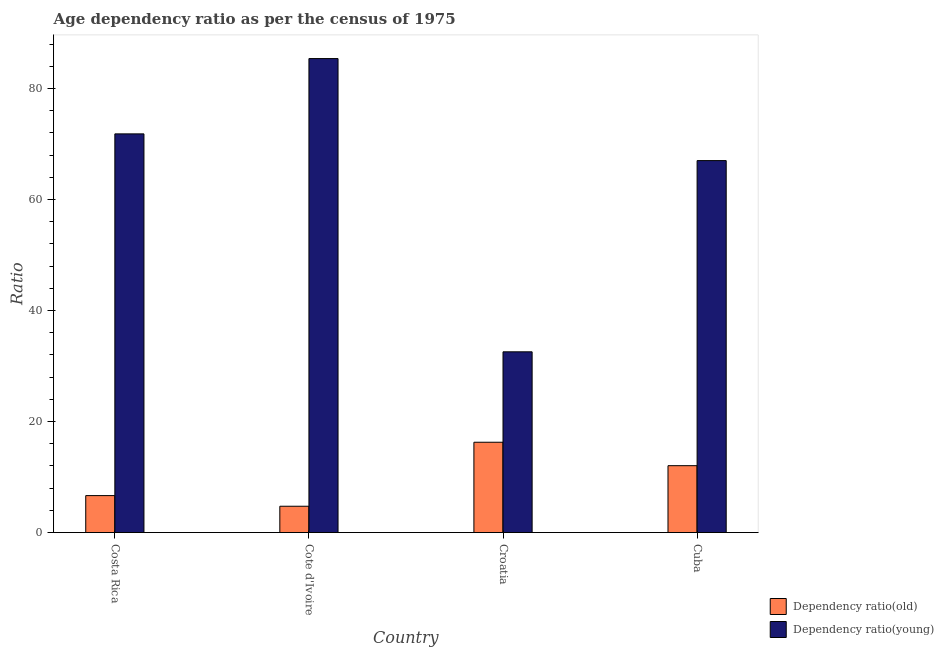Are the number of bars on each tick of the X-axis equal?
Offer a terse response. Yes. What is the label of the 2nd group of bars from the left?
Make the answer very short. Cote d'Ivoire. What is the age dependency ratio(young) in Croatia?
Give a very brief answer. 32.57. Across all countries, what is the maximum age dependency ratio(old)?
Make the answer very short. 16.28. Across all countries, what is the minimum age dependency ratio(old)?
Your answer should be very brief. 4.75. In which country was the age dependency ratio(old) maximum?
Offer a very short reply. Croatia. In which country was the age dependency ratio(young) minimum?
Ensure brevity in your answer.  Croatia. What is the total age dependency ratio(old) in the graph?
Your answer should be compact. 39.75. What is the difference between the age dependency ratio(young) in Croatia and that in Cuba?
Your answer should be very brief. -34.46. What is the difference between the age dependency ratio(old) in Croatia and the age dependency ratio(young) in Cote d'Ivoire?
Your response must be concise. -69.13. What is the average age dependency ratio(young) per country?
Your answer should be compact. 64.21. What is the difference between the age dependency ratio(old) and age dependency ratio(young) in Croatia?
Offer a very short reply. -16.29. In how many countries, is the age dependency ratio(young) greater than 4 ?
Offer a terse response. 4. What is the ratio of the age dependency ratio(old) in Croatia to that in Cuba?
Offer a terse response. 1.35. Is the age dependency ratio(young) in Costa Rica less than that in Cote d'Ivoire?
Your answer should be very brief. Yes. Is the difference between the age dependency ratio(old) in Costa Rica and Cuba greater than the difference between the age dependency ratio(young) in Costa Rica and Cuba?
Provide a succinct answer. No. What is the difference between the highest and the second highest age dependency ratio(old)?
Make the answer very short. 4.22. What is the difference between the highest and the lowest age dependency ratio(old)?
Your response must be concise. 11.53. In how many countries, is the age dependency ratio(young) greater than the average age dependency ratio(young) taken over all countries?
Ensure brevity in your answer.  3. Is the sum of the age dependency ratio(old) in Costa Rica and Cuba greater than the maximum age dependency ratio(young) across all countries?
Provide a short and direct response. No. What does the 2nd bar from the left in Croatia represents?
Provide a succinct answer. Dependency ratio(young). What does the 1st bar from the right in Costa Rica represents?
Provide a succinct answer. Dependency ratio(young). How many countries are there in the graph?
Your response must be concise. 4. What is the difference between two consecutive major ticks on the Y-axis?
Provide a short and direct response. 20. Are the values on the major ticks of Y-axis written in scientific E-notation?
Your answer should be compact. No. Does the graph contain any zero values?
Keep it short and to the point. No. Does the graph contain grids?
Your answer should be very brief. No. How are the legend labels stacked?
Your answer should be very brief. Vertical. What is the title of the graph?
Provide a short and direct response. Age dependency ratio as per the census of 1975. What is the label or title of the Y-axis?
Your answer should be very brief. Ratio. What is the Ratio of Dependency ratio(old) in Costa Rica?
Your response must be concise. 6.67. What is the Ratio in Dependency ratio(young) in Costa Rica?
Your answer should be very brief. 71.84. What is the Ratio in Dependency ratio(old) in Cote d'Ivoire?
Your answer should be compact. 4.75. What is the Ratio in Dependency ratio(young) in Cote d'Ivoire?
Give a very brief answer. 85.41. What is the Ratio in Dependency ratio(old) in Croatia?
Provide a short and direct response. 16.28. What is the Ratio of Dependency ratio(young) in Croatia?
Your answer should be very brief. 32.57. What is the Ratio of Dependency ratio(old) in Cuba?
Your answer should be compact. 12.06. What is the Ratio in Dependency ratio(young) in Cuba?
Your answer should be compact. 67.02. Across all countries, what is the maximum Ratio in Dependency ratio(old)?
Provide a succinct answer. 16.28. Across all countries, what is the maximum Ratio in Dependency ratio(young)?
Ensure brevity in your answer.  85.41. Across all countries, what is the minimum Ratio in Dependency ratio(old)?
Offer a very short reply. 4.75. Across all countries, what is the minimum Ratio in Dependency ratio(young)?
Offer a very short reply. 32.57. What is the total Ratio of Dependency ratio(old) in the graph?
Provide a succinct answer. 39.75. What is the total Ratio in Dependency ratio(young) in the graph?
Your answer should be very brief. 256.84. What is the difference between the Ratio in Dependency ratio(old) in Costa Rica and that in Cote d'Ivoire?
Ensure brevity in your answer.  1.92. What is the difference between the Ratio in Dependency ratio(young) in Costa Rica and that in Cote d'Ivoire?
Give a very brief answer. -13.57. What is the difference between the Ratio of Dependency ratio(old) in Costa Rica and that in Croatia?
Provide a short and direct response. -9.61. What is the difference between the Ratio in Dependency ratio(young) in Costa Rica and that in Croatia?
Provide a succinct answer. 39.27. What is the difference between the Ratio of Dependency ratio(old) in Costa Rica and that in Cuba?
Your answer should be compact. -5.39. What is the difference between the Ratio of Dependency ratio(young) in Costa Rica and that in Cuba?
Provide a succinct answer. 4.81. What is the difference between the Ratio of Dependency ratio(old) in Cote d'Ivoire and that in Croatia?
Provide a succinct answer. -11.53. What is the difference between the Ratio of Dependency ratio(young) in Cote d'Ivoire and that in Croatia?
Ensure brevity in your answer.  52.84. What is the difference between the Ratio of Dependency ratio(old) in Cote d'Ivoire and that in Cuba?
Provide a succinct answer. -7.31. What is the difference between the Ratio in Dependency ratio(young) in Cote d'Ivoire and that in Cuba?
Give a very brief answer. 18.38. What is the difference between the Ratio of Dependency ratio(old) in Croatia and that in Cuba?
Provide a succinct answer. 4.22. What is the difference between the Ratio of Dependency ratio(young) in Croatia and that in Cuba?
Provide a short and direct response. -34.46. What is the difference between the Ratio in Dependency ratio(old) in Costa Rica and the Ratio in Dependency ratio(young) in Cote d'Ivoire?
Provide a short and direct response. -78.74. What is the difference between the Ratio in Dependency ratio(old) in Costa Rica and the Ratio in Dependency ratio(young) in Croatia?
Your response must be concise. -25.9. What is the difference between the Ratio in Dependency ratio(old) in Costa Rica and the Ratio in Dependency ratio(young) in Cuba?
Your answer should be very brief. -60.36. What is the difference between the Ratio of Dependency ratio(old) in Cote d'Ivoire and the Ratio of Dependency ratio(young) in Croatia?
Give a very brief answer. -27.82. What is the difference between the Ratio of Dependency ratio(old) in Cote d'Ivoire and the Ratio of Dependency ratio(young) in Cuba?
Your response must be concise. -62.28. What is the difference between the Ratio in Dependency ratio(old) in Croatia and the Ratio in Dependency ratio(young) in Cuba?
Make the answer very short. -50.75. What is the average Ratio in Dependency ratio(old) per country?
Keep it short and to the point. 9.94. What is the average Ratio of Dependency ratio(young) per country?
Ensure brevity in your answer.  64.21. What is the difference between the Ratio of Dependency ratio(old) and Ratio of Dependency ratio(young) in Costa Rica?
Keep it short and to the point. -65.17. What is the difference between the Ratio in Dependency ratio(old) and Ratio in Dependency ratio(young) in Cote d'Ivoire?
Make the answer very short. -80.66. What is the difference between the Ratio in Dependency ratio(old) and Ratio in Dependency ratio(young) in Croatia?
Offer a very short reply. -16.29. What is the difference between the Ratio of Dependency ratio(old) and Ratio of Dependency ratio(young) in Cuba?
Your response must be concise. -54.97. What is the ratio of the Ratio in Dependency ratio(old) in Costa Rica to that in Cote d'Ivoire?
Your answer should be compact. 1.4. What is the ratio of the Ratio of Dependency ratio(young) in Costa Rica to that in Cote d'Ivoire?
Your answer should be very brief. 0.84. What is the ratio of the Ratio of Dependency ratio(old) in Costa Rica to that in Croatia?
Offer a very short reply. 0.41. What is the ratio of the Ratio in Dependency ratio(young) in Costa Rica to that in Croatia?
Your answer should be very brief. 2.21. What is the ratio of the Ratio of Dependency ratio(old) in Costa Rica to that in Cuba?
Keep it short and to the point. 0.55. What is the ratio of the Ratio of Dependency ratio(young) in Costa Rica to that in Cuba?
Ensure brevity in your answer.  1.07. What is the ratio of the Ratio in Dependency ratio(old) in Cote d'Ivoire to that in Croatia?
Ensure brevity in your answer.  0.29. What is the ratio of the Ratio in Dependency ratio(young) in Cote d'Ivoire to that in Croatia?
Ensure brevity in your answer.  2.62. What is the ratio of the Ratio of Dependency ratio(old) in Cote d'Ivoire to that in Cuba?
Provide a short and direct response. 0.39. What is the ratio of the Ratio in Dependency ratio(young) in Cote d'Ivoire to that in Cuba?
Ensure brevity in your answer.  1.27. What is the ratio of the Ratio of Dependency ratio(old) in Croatia to that in Cuba?
Your answer should be compact. 1.35. What is the ratio of the Ratio in Dependency ratio(young) in Croatia to that in Cuba?
Offer a very short reply. 0.49. What is the difference between the highest and the second highest Ratio of Dependency ratio(old)?
Offer a terse response. 4.22. What is the difference between the highest and the second highest Ratio of Dependency ratio(young)?
Offer a very short reply. 13.57. What is the difference between the highest and the lowest Ratio of Dependency ratio(old)?
Offer a terse response. 11.53. What is the difference between the highest and the lowest Ratio in Dependency ratio(young)?
Your answer should be very brief. 52.84. 